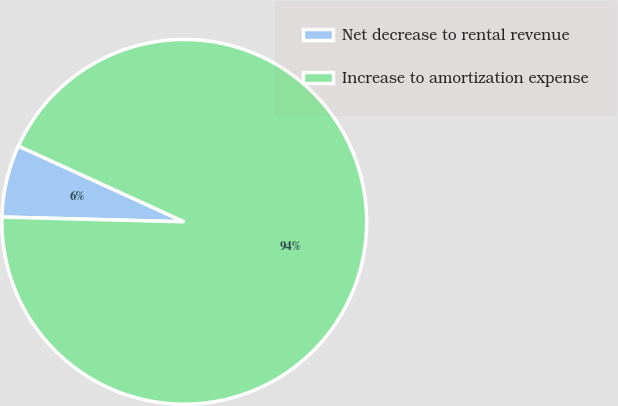Convert chart to OTSL. <chart><loc_0><loc_0><loc_500><loc_500><pie_chart><fcel>Net decrease to rental revenue<fcel>Increase to amortization expense<nl><fcel>6.41%<fcel>93.59%<nl></chart> 